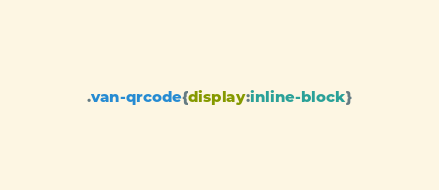Convert code to text. <code><loc_0><loc_0><loc_500><loc_500><_CSS_>.van-qrcode{display:inline-block}
</code> 